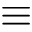<formula> <loc_0><loc_0><loc_500><loc_500>\equiv</formula> 